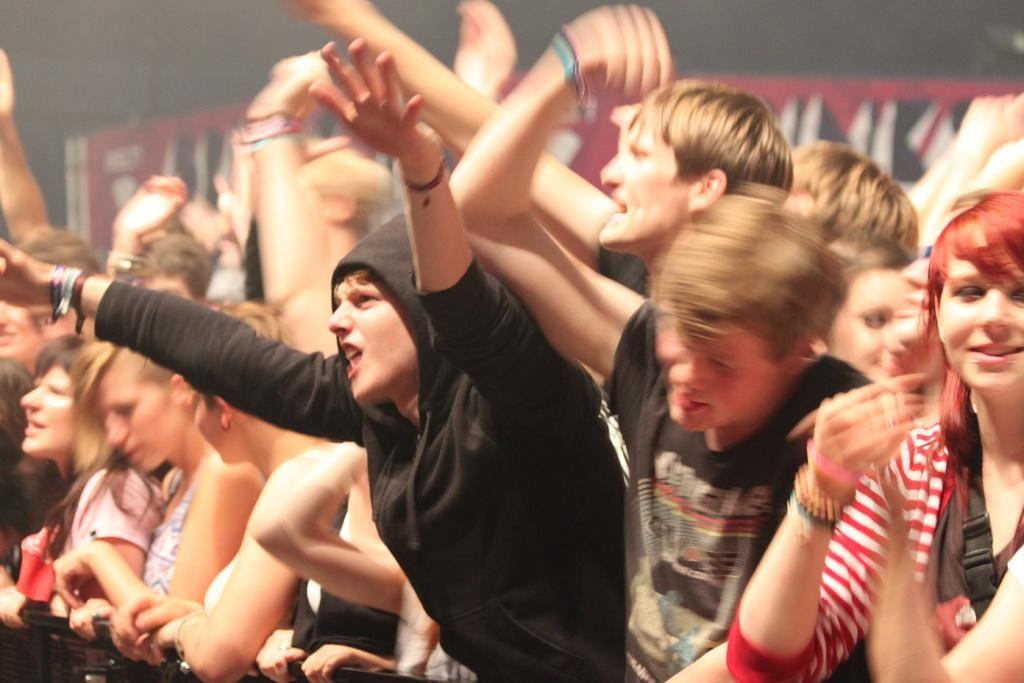How many people are in the image? There is a group of people in the image, but the exact number is not specified. What can be seen in the background of the image? There is a poster on a wall in the background of the image. What type of magic is being performed by the beggar in the image? There is no beggar or magic present in the image. 